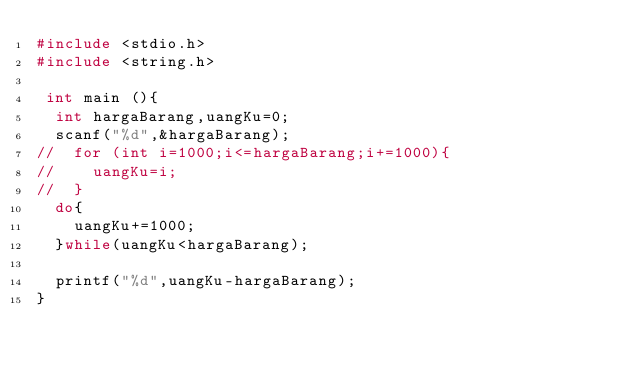<code> <loc_0><loc_0><loc_500><loc_500><_C++_>#include <stdio.h>
#include <string.h>

 int main (){
 	int hargaBarang,uangKu=0;
	scanf("%d",&hargaBarang);
// 	for (int i=1000;i<=hargaBarang;i+=1000){
//		uangKu=i;
//	}
	do{
		uangKu+=1000;
	}while(uangKu<hargaBarang);
	
	printf("%d",uangKu-hargaBarang);
}</code> 